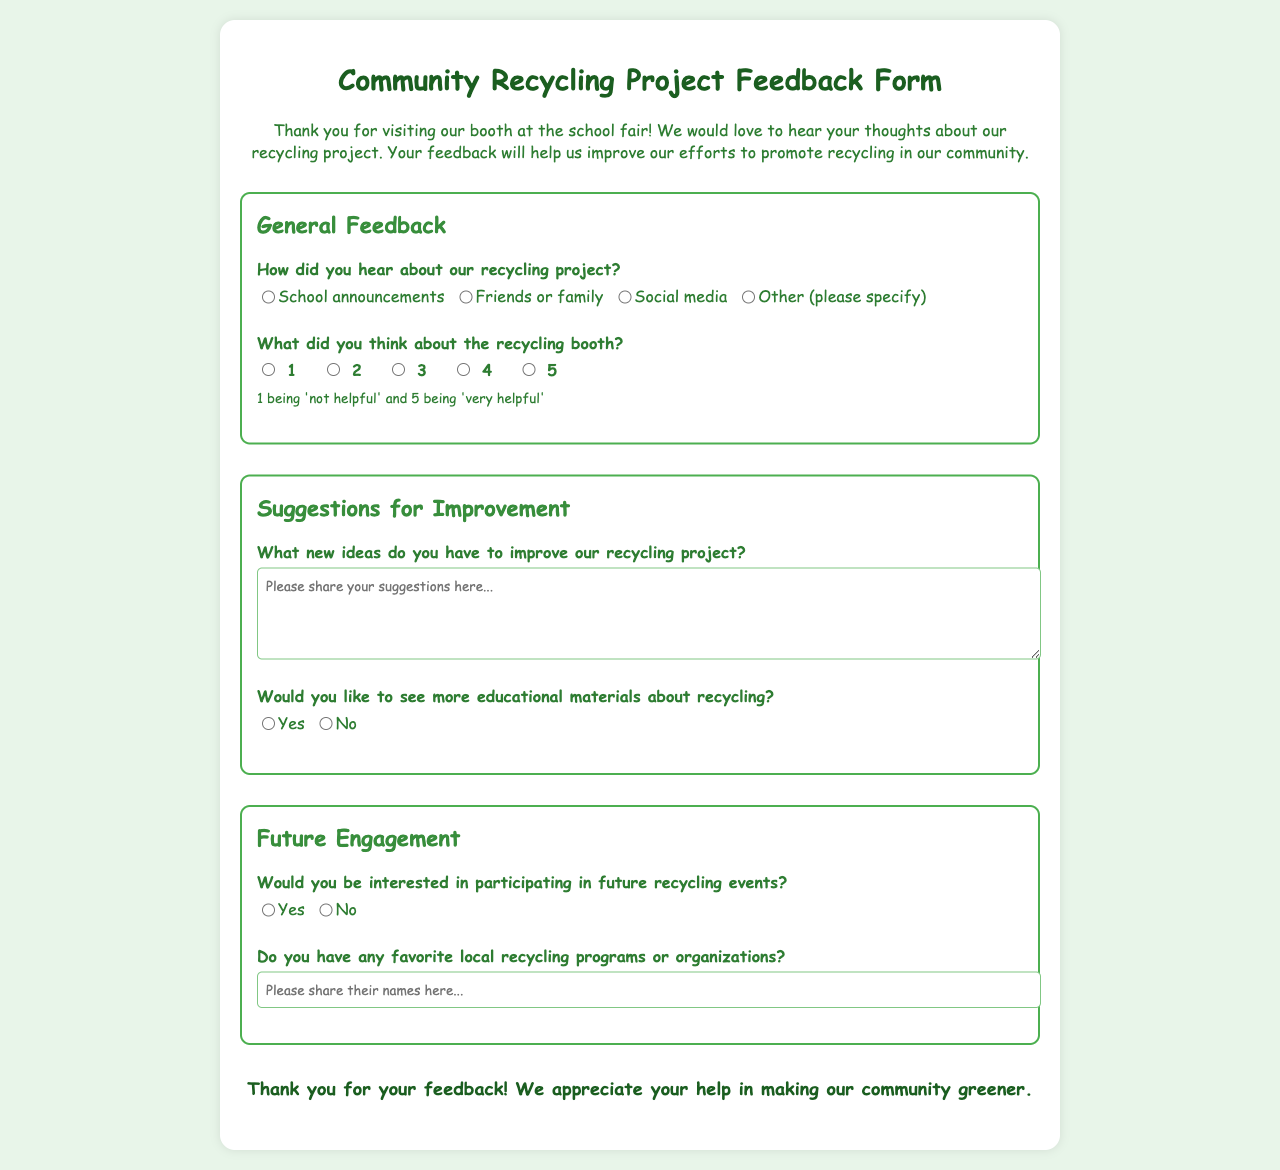How did the attendees hear about the recycling project? The form provides options for attendees to indicate how they heard about the project, including school announcements, friends or family, social media, or other.
Answer: School announcements What is the maximum rating an attendee could give to the recycling booth? The feedback form includes a rating scale from 1 to 5 for the booth rating, where 5 indicates 'very helpful.'
Answer: 5 What is one of the questions regarding suggestions for improving the project? The form asks attendees for new ideas to improve the recycling project, providing space for them to write their suggestions.
Answer: New ideas for improvement Would attendees like to see more educational materials about recycling? The form includes a question asking attendees if they would like to see more educational materials, with options for yes or no.
Answer: Yes What question is asked about future participation in recycling events? The feedback form asks if attendees would be interested in participating in future recycling events, with options for yes or no.
Answer: Yes 